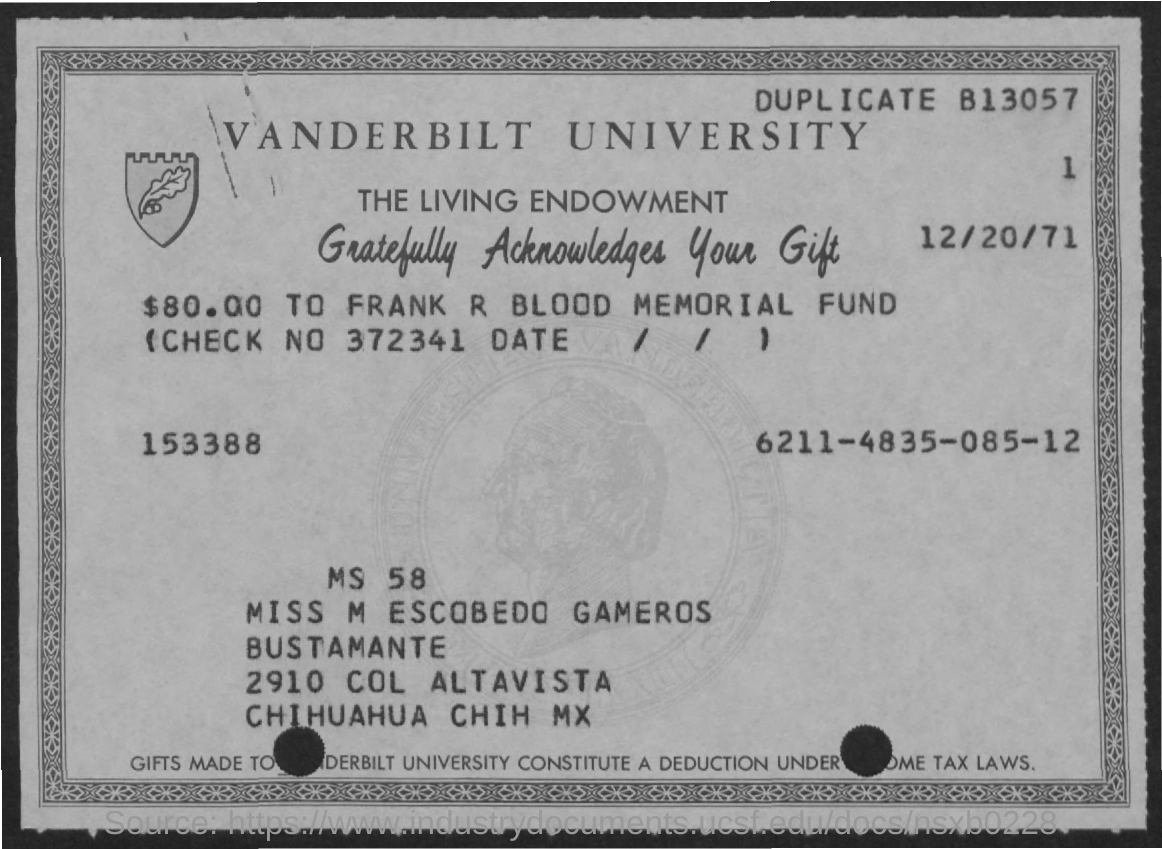Outline some significant characteristics in this image. The date mentioned is December 20, 1971. The amount mentioned on the given page is $80.00. Vanderbilt University is named. What is the check number mentioned? 372341... 